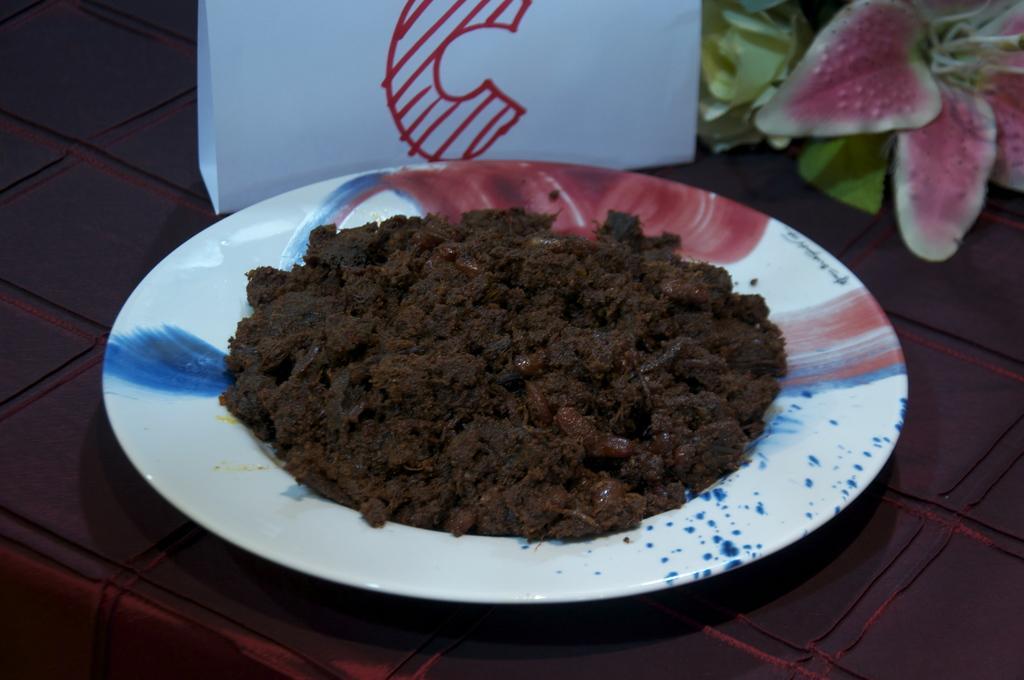In one or two sentences, can you explain what this image depicts? In this image I can see there is some food places in the plate and there is an artificial flower in the background. They are placed on the table. 